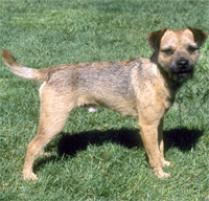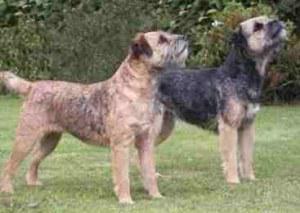The first image is the image on the left, the second image is the image on the right. Given the left and right images, does the statement "a dog has a leash on in the right image" hold true? Answer yes or no. No. 